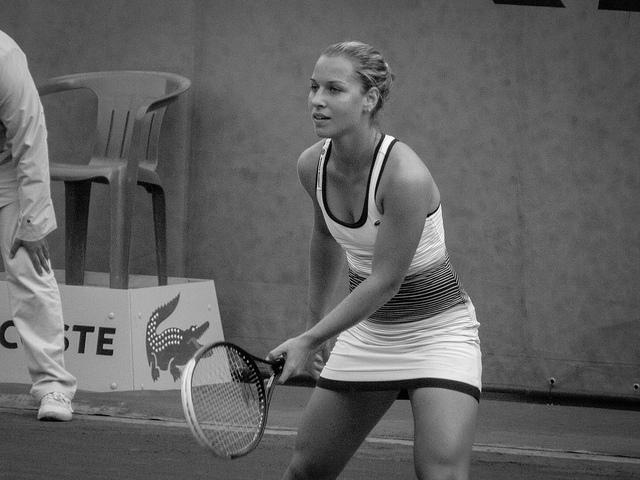What sport is she playing?
Give a very brief answer. Tennis. Is the hairdo shown a good choice for this sport?
Concise answer only. Yes. What letter is on the racket?
Quick response, please. None. Is she right or left handed?
Quick response, please. Left. 